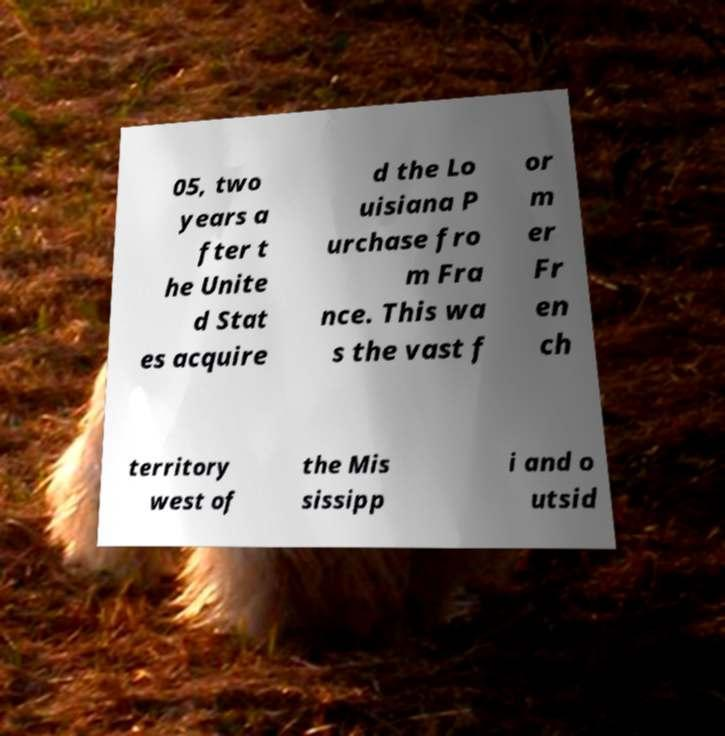Can you accurately transcribe the text from the provided image for me? 05, two years a fter t he Unite d Stat es acquire d the Lo uisiana P urchase fro m Fra nce. This wa s the vast f or m er Fr en ch territory west of the Mis sissipp i and o utsid 